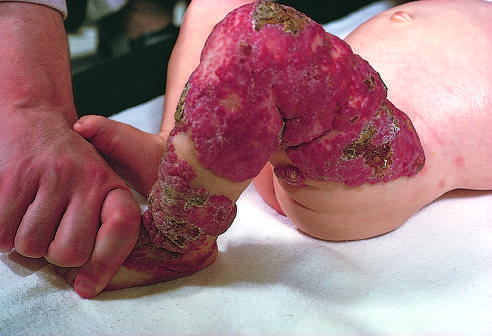what had undergone spontaneous regression?
Answer the question using a single word or phrase. Congenital capillary hemangioma at birth and at 2 years of age after the lesion 